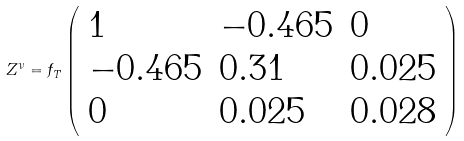<formula> <loc_0><loc_0><loc_500><loc_500>Z ^ { \nu } = f _ { T } \left ( \begin{array} { l l l } { 1 } & { - 0 . 4 6 5 } & { 0 } \\ { - 0 . 4 6 5 } & { 0 . 3 1 } & { 0 . 0 2 5 } \\ { 0 } & { 0 . 0 2 5 } & { 0 . 0 2 8 } \end{array} \right )</formula> 